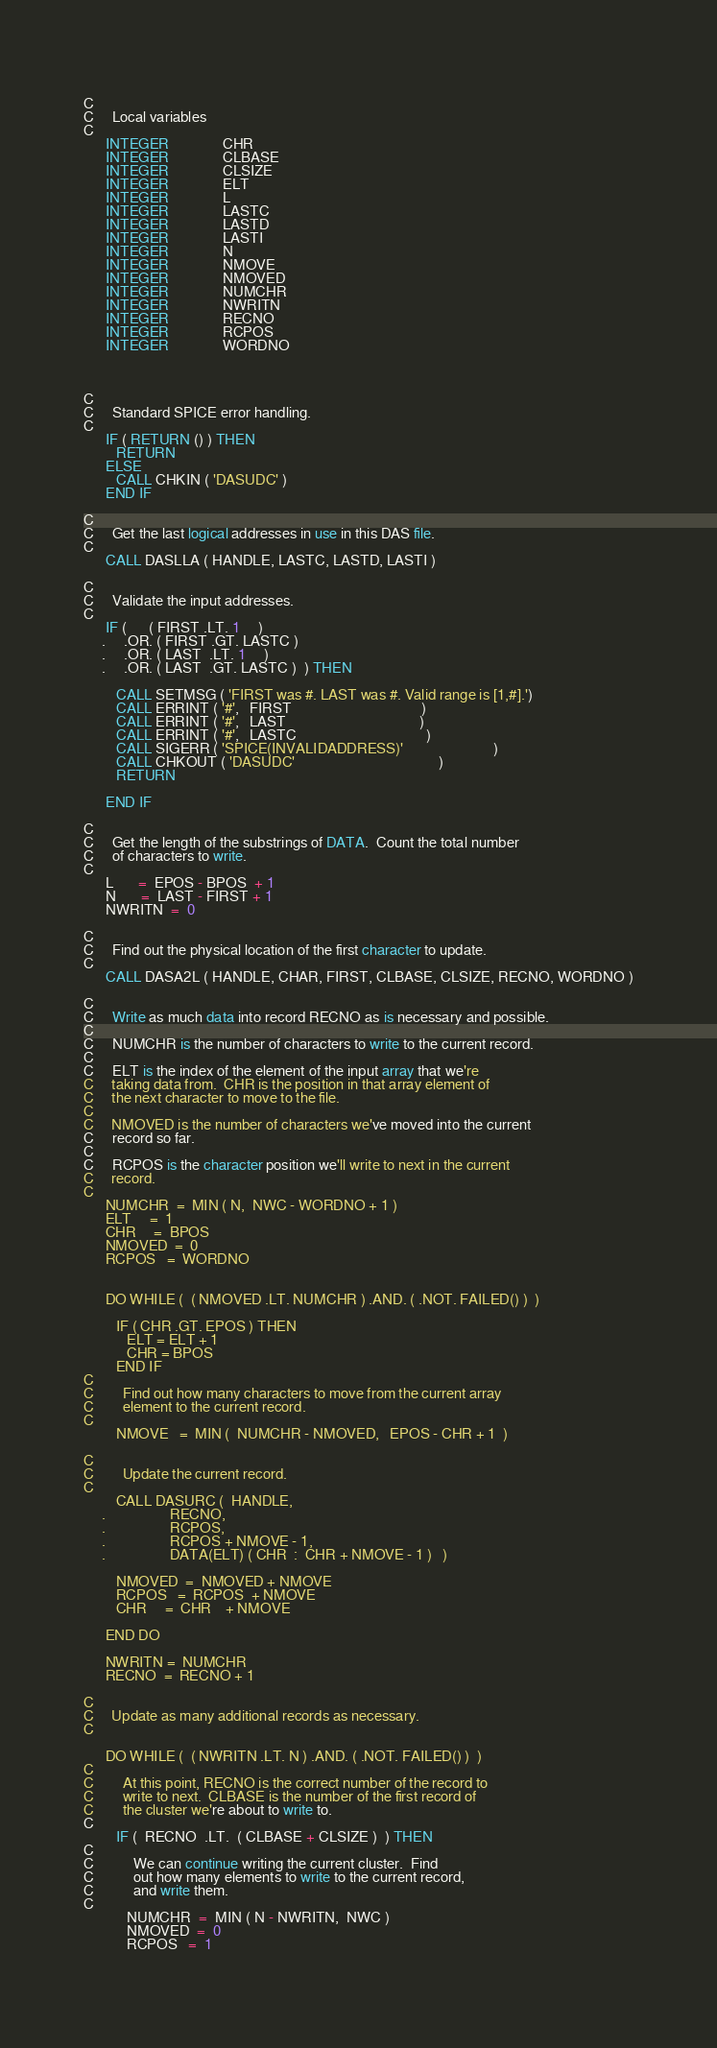Convert code to text. <code><loc_0><loc_0><loc_500><loc_500><_FORTRAN_> 
C
C     Local variables
C
      INTEGER               CHR
      INTEGER               CLBASE
      INTEGER               CLSIZE
      INTEGER               ELT
      INTEGER               L
      INTEGER               LASTC
      INTEGER               LASTD
      INTEGER               LASTI
      INTEGER               N
      INTEGER               NMOVE
      INTEGER               NMOVED
      INTEGER               NUMCHR
      INTEGER               NWRITN
      INTEGER               RECNO
      INTEGER               RCPOS
      INTEGER               WORDNO
 
 
 
C
C     Standard SPICE error handling.
C
      IF ( RETURN () ) THEN
         RETURN
      ELSE
         CALL CHKIN ( 'DASUDC' )
      END IF
 
C
C     Get the last logical addresses in use in this DAS file.
C
      CALL DASLLA ( HANDLE, LASTC, LASTD, LASTI )
 
C
C     Validate the input addresses.
C
      IF (      ( FIRST .LT. 1     )
     .     .OR. ( FIRST .GT. LASTC )
     .     .OR. ( LAST  .LT. 1     )
     .     .OR. ( LAST  .GT. LASTC )  ) THEN
 
         CALL SETMSG ( 'FIRST was #. LAST was #. Valid range is [1,#].')
         CALL ERRINT ( '#',   FIRST                                    )
         CALL ERRINT ( '#',   LAST                                     )
         CALL ERRINT ( '#',   LASTC                                    )
         CALL SIGERR ( 'SPICE(INVALIDADDRESS)'                         )
         CALL CHKOUT ( 'DASUDC'                                        )
         RETURN
 
      END IF
 
C
C     Get the length of the substrings of DATA.  Count the total number
C     of characters to write.
C
      L       =  EPOS - BPOS  + 1
      N       =  LAST - FIRST + 1
      NWRITN  =  0
 
C
C     Find out the physical location of the first character to update.
C
      CALL DASA2L ( HANDLE, CHAR, FIRST, CLBASE, CLSIZE, RECNO, WORDNO )
 
C
C     Write as much data into record RECNO as is necessary and possible.
C
C     NUMCHR is the number of characters to write to the current record.
C
C     ELT is the index of the element of the input array that we're
C     taking data from.  CHR is the position in that array element of
C     the next character to move to the file.
C
C     NMOVED is the number of characters we've moved into the current
C     record so far.
C
C     RCPOS is the character position we'll write to next in the current
C     record.
C
      NUMCHR  =  MIN ( N,  NWC - WORDNO + 1 )
      ELT     =  1
      CHR     =  BPOS
      NMOVED  =  0
      RCPOS   =  WORDNO
 
 
      DO WHILE (  ( NMOVED .LT. NUMCHR ) .AND. ( .NOT. FAILED() )  )
 
         IF ( CHR .GT. EPOS ) THEN
            ELT = ELT + 1
            CHR = BPOS
         END IF
C
C        Find out how many characters to move from the current array
C        element to the current record.
C
         NMOVE   =  MIN (  NUMCHR - NMOVED,   EPOS - CHR + 1  )
 
C
C        Update the current record.
C
         CALL DASURC (  HANDLE,
     .                  RECNO,
     .                  RCPOS,
     .                  RCPOS + NMOVE - 1,
     .                  DATA(ELT) ( CHR  :  CHR + NMOVE - 1 )   )
 
         NMOVED  =  NMOVED + NMOVE
         RCPOS   =  RCPOS  + NMOVE
         CHR     =  CHR    + NMOVE
 
      END DO
 
      NWRITN =  NUMCHR
      RECNO  =  RECNO + 1
 
C
C     Update as many additional records as necessary.
C
 
      DO WHILE (  ( NWRITN .LT. N ) .AND. ( .NOT. FAILED() )  )
C
C        At this point, RECNO is the correct number of the record to
C        write to next.  CLBASE is the number of the first record of
C        the cluster we're about to write to.
C
         IF (  RECNO  .LT.  ( CLBASE + CLSIZE )  ) THEN
C
C           We can continue writing the current cluster.  Find
C           out how many elements to write to the current record,
C           and write them.
C
            NUMCHR  =  MIN ( N - NWRITN,  NWC )
            NMOVED  =  0
            RCPOS   =  1
 </code> 